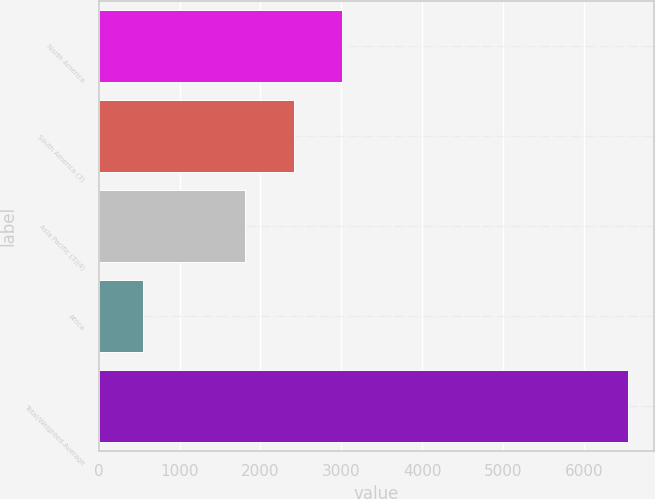Convert chart. <chart><loc_0><loc_0><loc_500><loc_500><bar_chart><fcel>North America<fcel>South America (3)<fcel>Asia Pacific (3)(4)<fcel>Africa<fcel>Total/Weighted-Average<nl><fcel>3010.4<fcel>2410.7<fcel>1811<fcel>546<fcel>6543<nl></chart> 